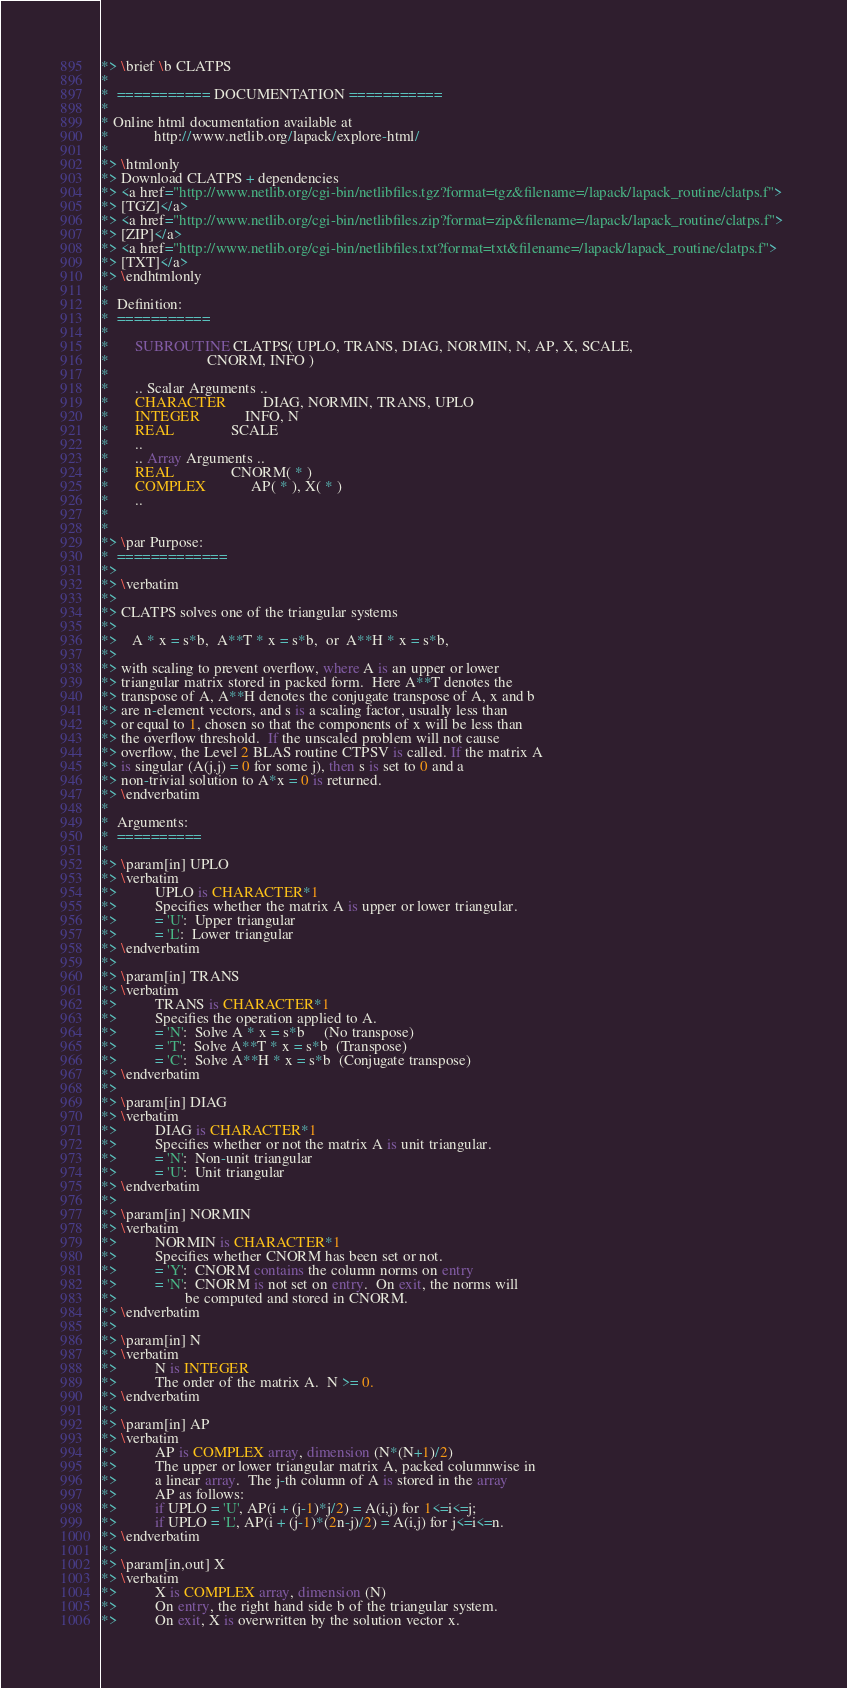<code> <loc_0><loc_0><loc_500><loc_500><_FORTRAN_>*> \brief \b CLATPS
*
*  =========== DOCUMENTATION ===========
*
* Online html documentation available at 
*            http://www.netlib.org/lapack/explore-html/ 
*
*> \htmlonly
*> Download CLATPS + dependencies 
*> <a href="http://www.netlib.org/cgi-bin/netlibfiles.tgz?format=tgz&filename=/lapack/lapack_routine/clatps.f"> 
*> [TGZ]</a> 
*> <a href="http://www.netlib.org/cgi-bin/netlibfiles.zip?format=zip&filename=/lapack/lapack_routine/clatps.f"> 
*> [ZIP]</a> 
*> <a href="http://www.netlib.org/cgi-bin/netlibfiles.txt?format=txt&filename=/lapack/lapack_routine/clatps.f"> 
*> [TXT]</a>
*> \endhtmlonly 
*
*  Definition:
*  ===========
*
*       SUBROUTINE CLATPS( UPLO, TRANS, DIAG, NORMIN, N, AP, X, SCALE,
*                          CNORM, INFO )
* 
*       .. Scalar Arguments ..
*       CHARACTER          DIAG, NORMIN, TRANS, UPLO
*       INTEGER            INFO, N
*       REAL               SCALE
*       ..
*       .. Array Arguments ..
*       REAL               CNORM( * )
*       COMPLEX            AP( * ), X( * )
*       ..
*  
*
*> \par Purpose:
*  =============
*>
*> \verbatim
*>
*> CLATPS solves one of the triangular systems
*>
*>    A * x = s*b,  A**T * x = s*b,  or  A**H * x = s*b,
*>
*> with scaling to prevent overflow, where A is an upper or lower
*> triangular matrix stored in packed form.  Here A**T denotes the
*> transpose of A, A**H denotes the conjugate transpose of A, x and b
*> are n-element vectors, and s is a scaling factor, usually less than
*> or equal to 1, chosen so that the components of x will be less than
*> the overflow threshold.  If the unscaled problem will not cause
*> overflow, the Level 2 BLAS routine CTPSV is called. If the matrix A
*> is singular (A(j,j) = 0 for some j), then s is set to 0 and a
*> non-trivial solution to A*x = 0 is returned.
*> \endverbatim
*
*  Arguments:
*  ==========
*
*> \param[in] UPLO
*> \verbatim
*>          UPLO is CHARACTER*1
*>          Specifies whether the matrix A is upper or lower triangular.
*>          = 'U':  Upper triangular
*>          = 'L':  Lower triangular
*> \endverbatim
*>
*> \param[in] TRANS
*> \verbatim
*>          TRANS is CHARACTER*1
*>          Specifies the operation applied to A.
*>          = 'N':  Solve A * x = s*b     (No transpose)
*>          = 'T':  Solve A**T * x = s*b  (Transpose)
*>          = 'C':  Solve A**H * x = s*b  (Conjugate transpose)
*> \endverbatim
*>
*> \param[in] DIAG
*> \verbatim
*>          DIAG is CHARACTER*1
*>          Specifies whether or not the matrix A is unit triangular.
*>          = 'N':  Non-unit triangular
*>          = 'U':  Unit triangular
*> \endverbatim
*>
*> \param[in] NORMIN
*> \verbatim
*>          NORMIN is CHARACTER*1
*>          Specifies whether CNORM has been set or not.
*>          = 'Y':  CNORM contains the column norms on entry
*>          = 'N':  CNORM is not set on entry.  On exit, the norms will
*>                  be computed and stored in CNORM.
*> \endverbatim
*>
*> \param[in] N
*> \verbatim
*>          N is INTEGER
*>          The order of the matrix A.  N >= 0.
*> \endverbatim
*>
*> \param[in] AP
*> \verbatim
*>          AP is COMPLEX array, dimension (N*(N+1)/2)
*>          The upper or lower triangular matrix A, packed columnwise in
*>          a linear array.  The j-th column of A is stored in the array
*>          AP as follows:
*>          if UPLO = 'U', AP(i + (j-1)*j/2) = A(i,j) for 1<=i<=j;
*>          if UPLO = 'L', AP(i + (j-1)*(2n-j)/2) = A(i,j) for j<=i<=n.
*> \endverbatim
*>
*> \param[in,out] X
*> \verbatim
*>          X is COMPLEX array, dimension (N)
*>          On entry, the right hand side b of the triangular system.
*>          On exit, X is overwritten by the solution vector x.</code> 